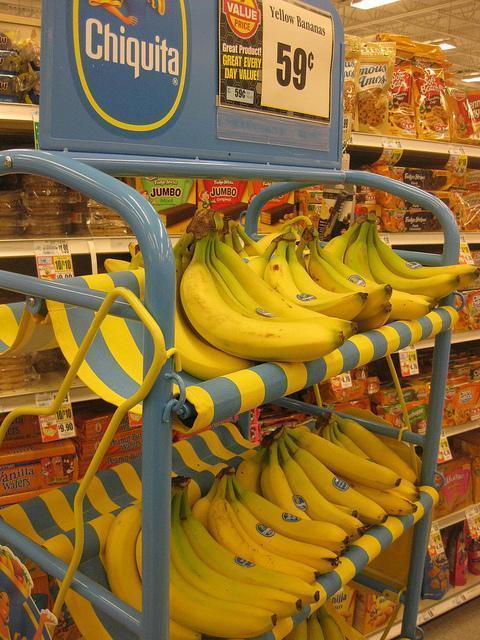How many bunches of bananas are there?
Give a very brief answer. 7. How many bananas are there?
Give a very brief answer. 9. 